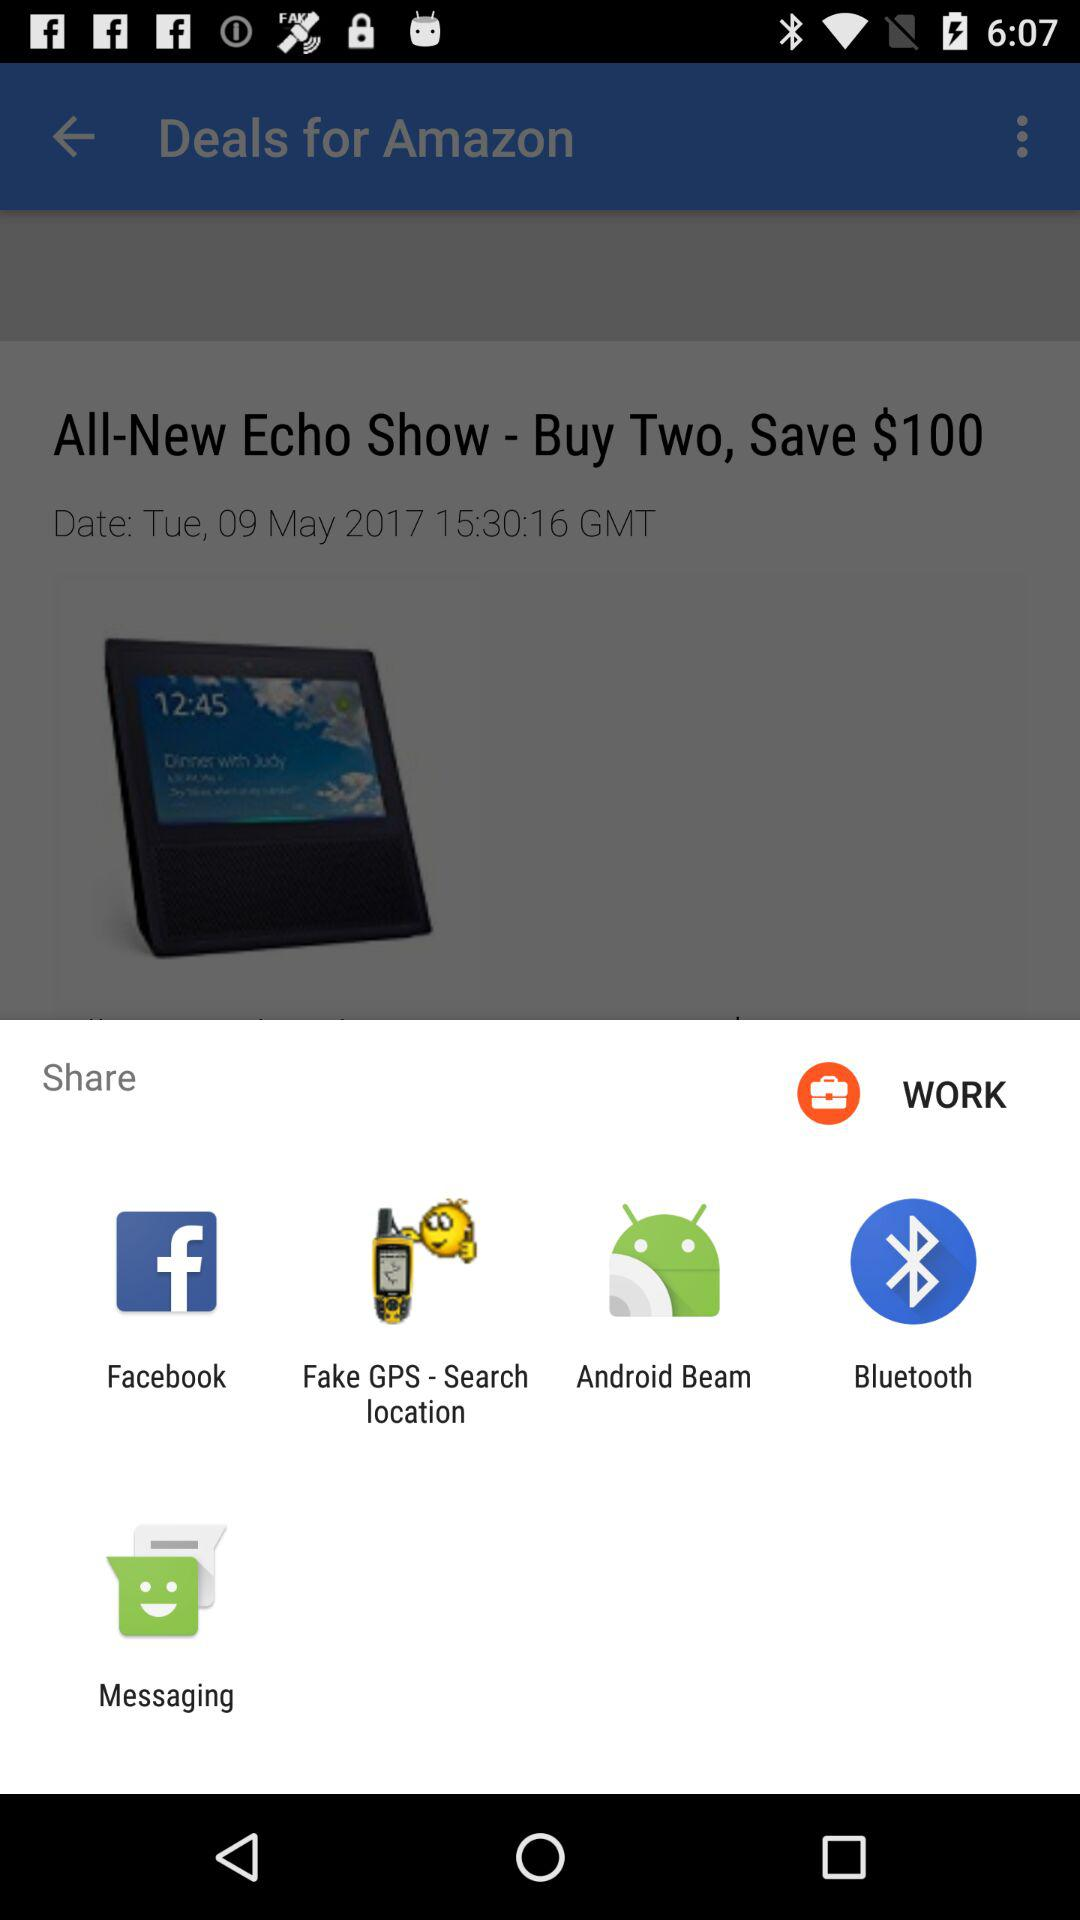How much is the "All-New Echo Show"?
When the provided information is insufficient, respond with <no answer>. <no answer> 